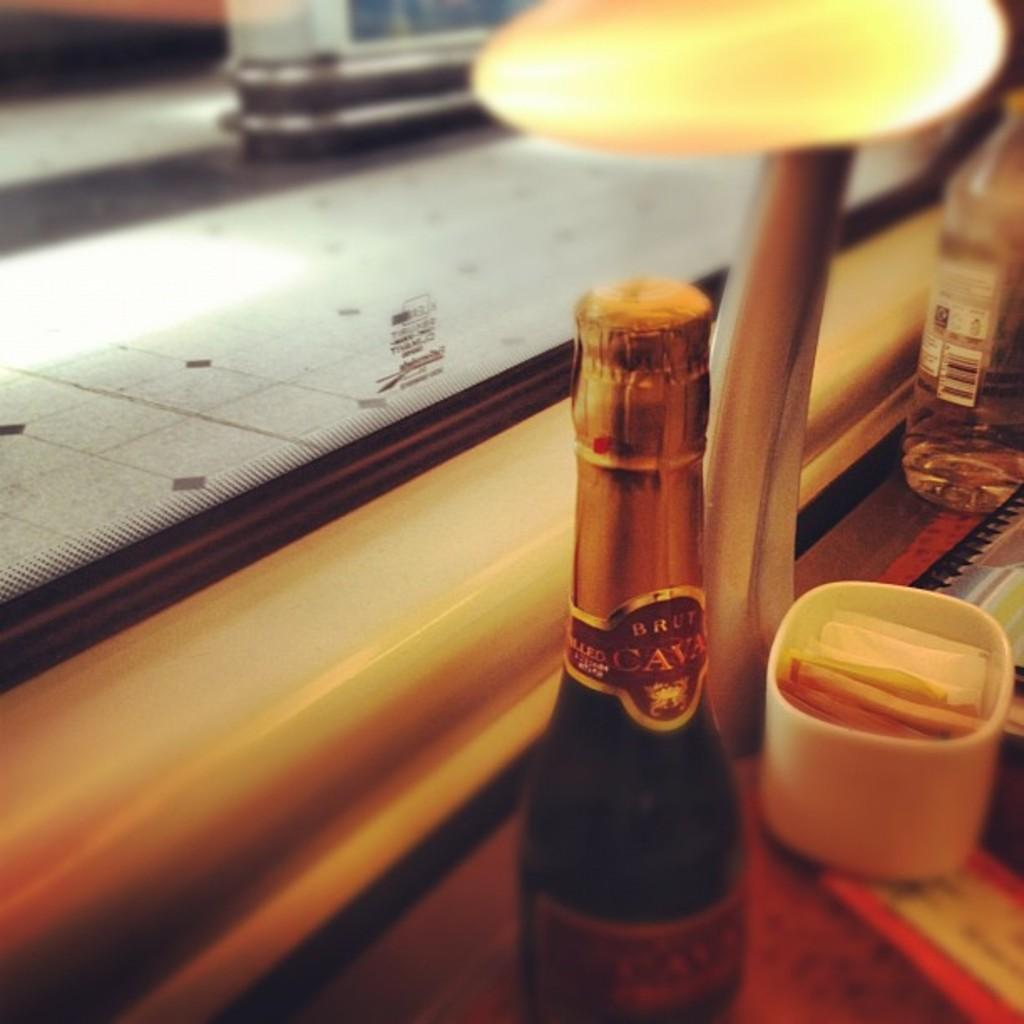<image>
Offer a succinct explanation of the picture presented. A bottle that says CAVA on the foil wrapper sits on a table. 